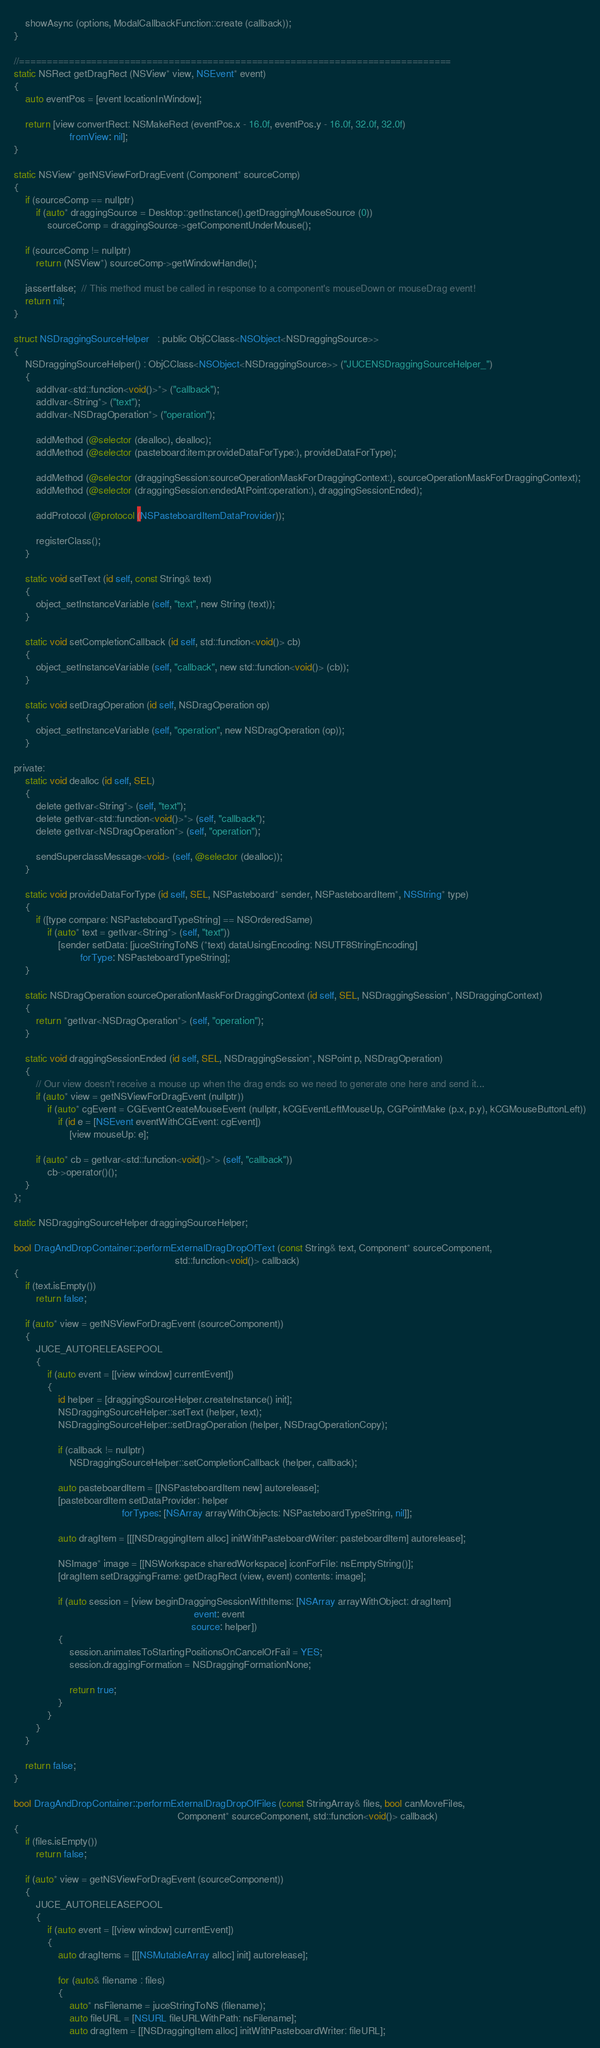<code> <loc_0><loc_0><loc_500><loc_500><_ObjectiveC_>    showAsync (options, ModalCallbackFunction::create (callback));
}

//==============================================================================
static NSRect getDragRect (NSView* view, NSEvent* event)
{
    auto eventPos = [event locationInWindow];

    return [view convertRect: NSMakeRect (eventPos.x - 16.0f, eventPos.y - 16.0f, 32.0f, 32.0f)
                    fromView: nil];
}

static NSView* getNSViewForDragEvent (Component* sourceComp)
{
    if (sourceComp == nullptr)
        if (auto* draggingSource = Desktop::getInstance().getDraggingMouseSource (0))
            sourceComp = draggingSource->getComponentUnderMouse();

    if (sourceComp != nullptr)
        return (NSView*) sourceComp->getWindowHandle();

    jassertfalse;  // This method must be called in response to a component's mouseDown or mouseDrag event!
    return nil;
}

struct NSDraggingSourceHelper   : public ObjCClass<NSObject<NSDraggingSource>>
{
    NSDraggingSourceHelper() : ObjCClass<NSObject<NSDraggingSource>> ("JUCENSDraggingSourceHelper_")
    {
        addIvar<std::function<void()>*> ("callback");
        addIvar<String*> ("text");
        addIvar<NSDragOperation*> ("operation");

        addMethod (@selector (dealloc), dealloc);
        addMethod (@selector (pasteboard:item:provideDataForType:), provideDataForType);

        addMethod (@selector (draggingSession:sourceOperationMaskForDraggingContext:), sourceOperationMaskForDraggingContext);
        addMethod (@selector (draggingSession:endedAtPoint:operation:), draggingSessionEnded);

        addProtocol (@protocol (NSPasteboardItemDataProvider));

        registerClass();
    }

    static void setText (id self, const String& text)
    {
        object_setInstanceVariable (self, "text", new String (text));
    }

    static void setCompletionCallback (id self, std::function<void()> cb)
    {
        object_setInstanceVariable (self, "callback", new std::function<void()> (cb));
    }

    static void setDragOperation (id self, NSDragOperation op)
    {
        object_setInstanceVariable (self, "operation", new NSDragOperation (op));
    }

private:
    static void dealloc (id self, SEL)
    {
        delete getIvar<String*> (self, "text");
        delete getIvar<std::function<void()>*> (self, "callback");
        delete getIvar<NSDragOperation*> (self, "operation");

        sendSuperclassMessage<void> (self, @selector (dealloc));
    }

    static void provideDataForType (id self, SEL, NSPasteboard* sender, NSPasteboardItem*, NSString* type)
    {
        if ([type compare: NSPasteboardTypeString] == NSOrderedSame)
            if (auto* text = getIvar<String*> (self, "text"))
                [sender setData: [juceStringToNS (*text) dataUsingEncoding: NSUTF8StringEncoding]
                        forType: NSPasteboardTypeString];
    }

    static NSDragOperation sourceOperationMaskForDraggingContext (id self, SEL, NSDraggingSession*, NSDraggingContext)
    {
        return *getIvar<NSDragOperation*> (self, "operation");
    }

    static void draggingSessionEnded (id self, SEL, NSDraggingSession*, NSPoint p, NSDragOperation)
    {
        // Our view doesn't receive a mouse up when the drag ends so we need to generate one here and send it...
        if (auto* view = getNSViewForDragEvent (nullptr))
            if (auto* cgEvent = CGEventCreateMouseEvent (nullptr, kCGEventLeftMouseUp, CGPointMake (p.x, p.y), kCGMouseButtonLeft))
                if (id e = [NSEvent eventWithCGEvent: cgEvent])
                    [view mouseUp: e];

        if (auto* cb = getIvar<std::function<void()>*> (self, "callback"))
            cb->operator()();
    }
};

static NSDraggingSourceHelper draggingSourceHelper;

bool DragAndDropContainer::performExternalDragDropOfText (const String& text, Component* sourceComponent,
                                                          std::function<void()> callback)
{
    if (text.isEmpty())
        return false;

    if (auto* view = getNSViewForDragEvent (sourceComponent))
    {
        JUCE_AUTORELEASEPOOL
        {
            if (auto event = [[view window] currentEvent])
            {
                id helper = [draggingSourceHelper.createInstance() init];
                NSDraggingSourceHelper::setText (helper, text);
                NSDraggingSourceHelper::setDragOperation (helper, NSDragOperationCopy);

                if (callback != nullptr)
                    NSDraggingSourceHelper::setCompletionCallback (helper, callback);

                auto pasteboardItem = [[NSPasteboardItem new] autorelease];
                [pasteboardItem setDataProvider: helper
                                       forTypes: [NSArray arrayWithObjects: NSPasteboardTypeString, nil]];

                auto dragItem = [[[NSDraggingItem alloc] initWithPasteboardWriter: pasteboardItem] autorelease];

                NSImage* image = [[NSWorkspace sharedWorkspace] iconForFile: nsEmptyString()];
                [dragItem setDraggingFrame: getDragRect (view, event) contents: image];

                if (auto session = [view beginDraggingSessionWithItems: [NSArray arrayWithObject: dragItem]
                                                                 event: event
                                                                source: helper])
                {
                    session.animatesToStartingPositionsOnCancelOrFail = YES;
                    session.draggingFormation = NSDraggingFormationNone;

                    return true;
                }
            }
        }
    }

    return false;
}

bool DragAndDropContainer::performExternalDragDropOfFiles (const StringArray& files, bool canMoveFiles,
                                                           Component* sourceComponent, std::function<void()> callback)
{
    if (files.isEmpty())
        return false;

    if (auto* view = getNSViewForDragEvent (sourceComponent))
    {
        JUCE_AUTORELEASEPOOL
        {
            if (auto event = [[view window] currentEvent])
            {
                auto dragItems = [[[NSMutableArray alloc] init] autorelease];

                for (auto& filename : files)
                {
                    auto* nsFilename = juceStringToNS (filename);
                    auto fileURL = [NSURL fileURLWithPath: nsFilename];
                    auto dragItem = [[NSDraggingItem alloc] initWithPasteboardWriter: fileURL];
</code> 